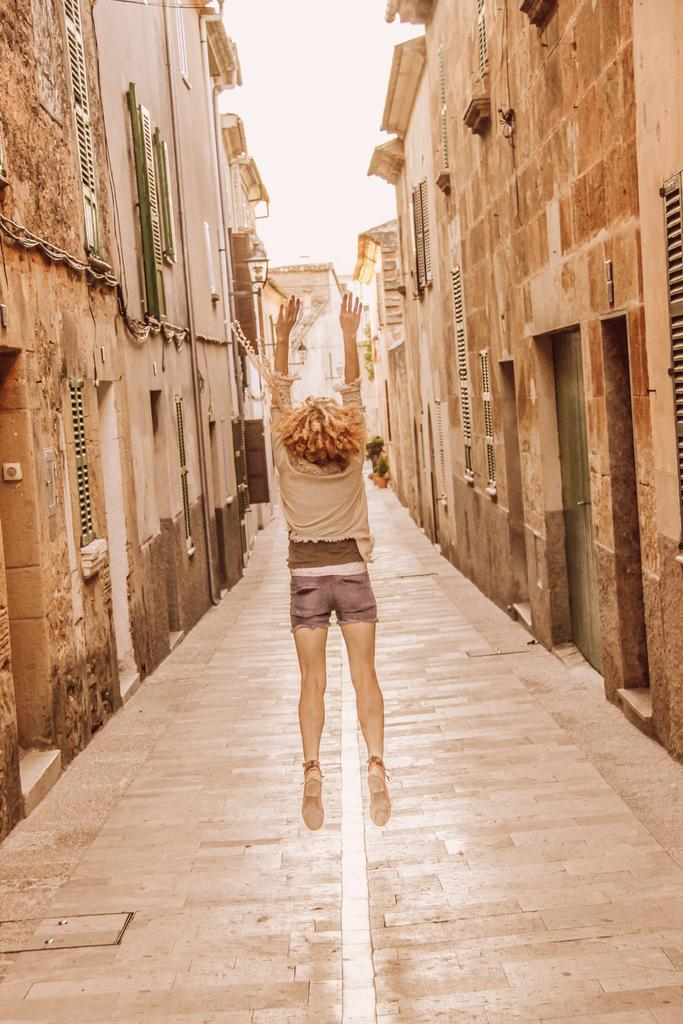What can be seen on both sides of the image? There are houses on both the right and left sides of the image. What is the main subject in the center of the image? There is a woman in the center of the image. What is the woman doing in the image? The woman is jumping. What is at the bottom of the image? There is a walkway at the bottom of the image. How many ducks are swimming in the walkway in the image? There are no ducks present in the image; it features houses, a woman jumping, and a walkway. What type of gardening tool is being used by the woman in the image? The woman in the image is not using any gardening tools; she is jumping. 